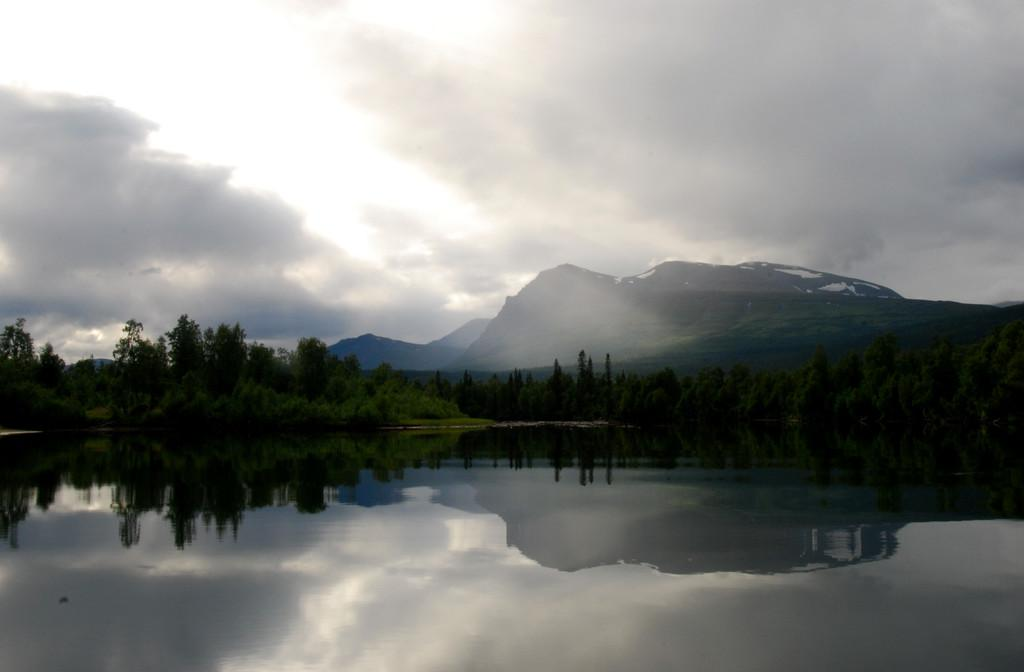What is the primary element visible in the image? There is water in the image. What type of vegetation can be seen in the image? Plants and trees are visible in the image. What geographical features are present in the image? There are hills in the image. What is the condition of the hills in the image? Snow is visible on the hills. What is visible in the sky in the image? The sky is visible in the image, and clouds are present. What type of soap is being used to clean the grain in the image? There is no soap or grain present in the image. 